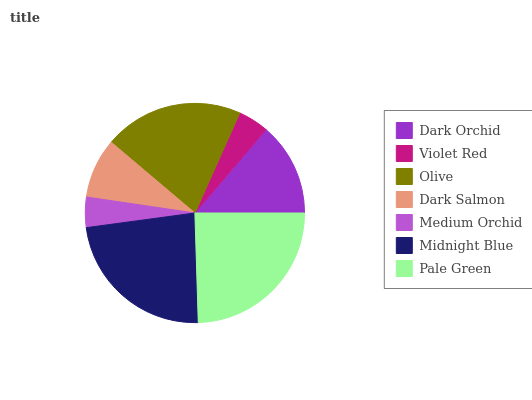Is Medium Orchid the minimum?
Answer yes or no. Yes. Is Pale Green the maximum?
Answer yes or no. Yes. Is Violet Red the minimum?
Answer yes or no. No. Is Violet Red the maximum?
Answer yes or no. No. Is Dark Orchid greater than Violet Red?
Answer yes or no. Yes. Is Violet Red less than Dark Orchid?
Answer yes or no. Yes. Is Violet Red greater than Dark Orchid?
Answer yes or no. No. Is Dark Orchid less than Violet Red?
Answer yes or no. No. Is Dark Orchid the high median?
Answer yes or no. Yes. Is Dark Orchid the low median?
Answer yes or no. Yes. Is Violet Red the high median?
Answer yes or no. No. Is Medium Orchid the low median?
Answer yes or no. No. 